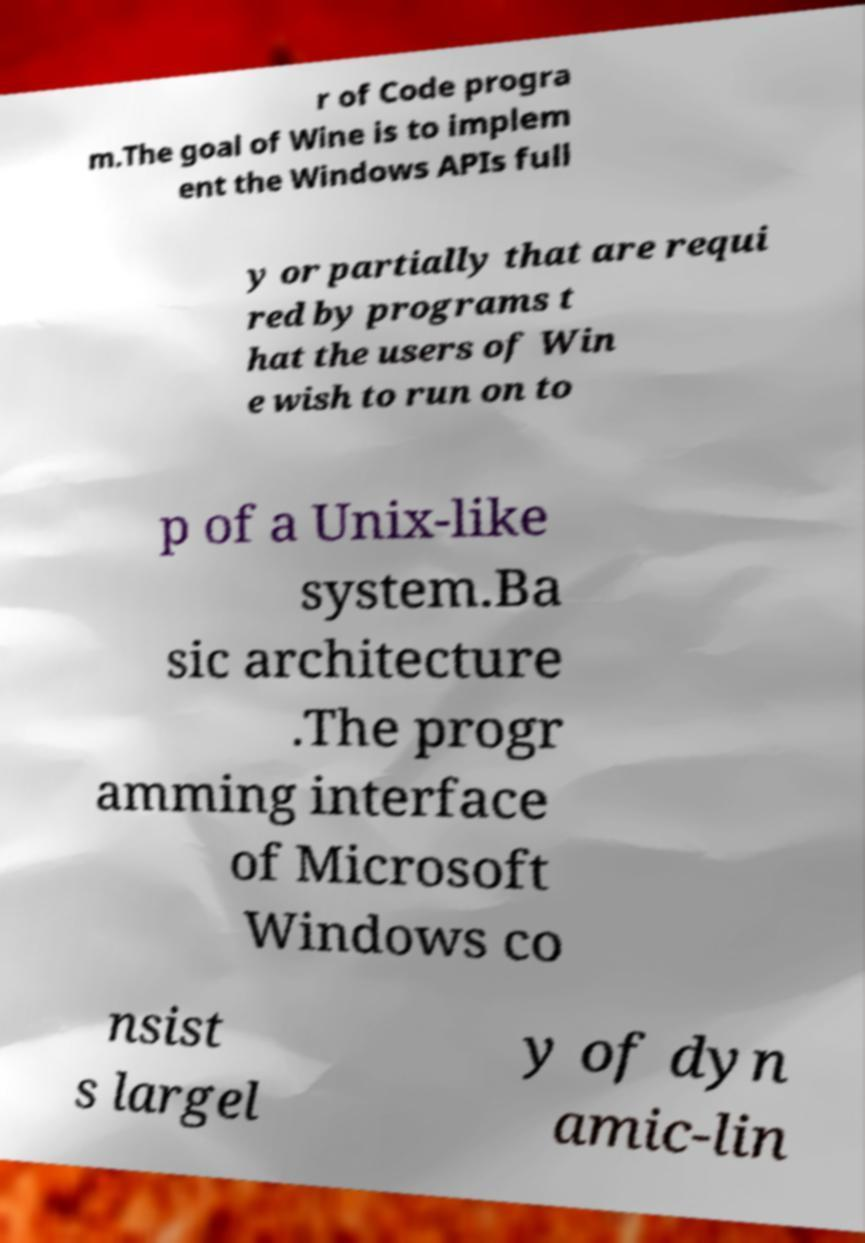Can you accurately transcribe the text from the provided image for me? r of Code progra m.The goal of Wine is to implem ent the Windows APIs full y or partially that are requi red by programs t hat the users of Win e wish to run on to p of a Unix-like system.Ba sic architecture .The progr amming interface of Microsoft Windows co nsist s largel y of dyn amic-lin 